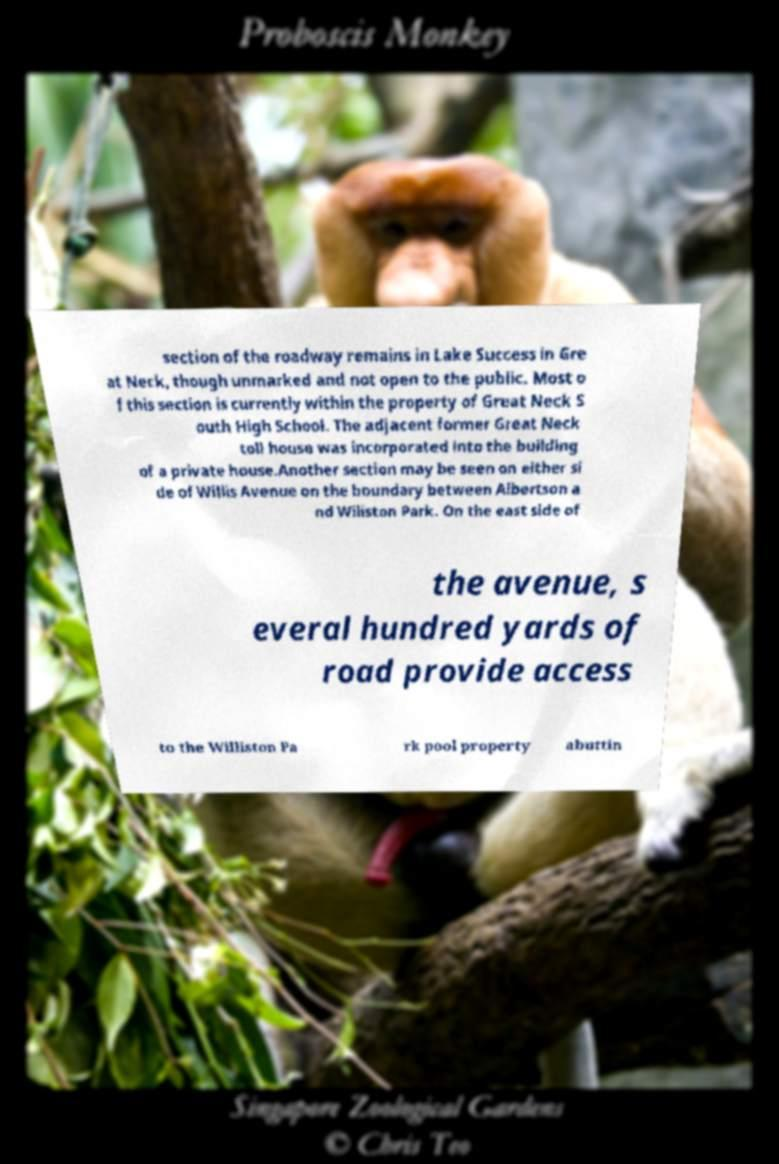Can you read and provide the text displayed in the image?This photo seems to have some interesting text. Can you extract and type it out for me? section of the roadway remains in Lake Success in Gre at Neck, though unmarked and not open to the public. Most o f this section is currently within the property of Great Neck S outh High School. The adjacent former Great Neck toll house was incorporated into the building of a private house.Another section may be seen on either si de of Willis Avenue on the boundary between Albertson a nd Wiliston Park. On the east side of the avenue, s everal hundred yards of road provide access to the Williston Pa rk pool property abuttin 